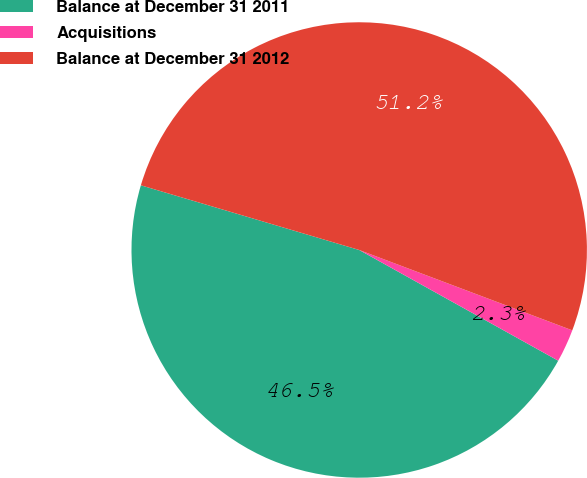<chart> <loc_0><loc_0><loc_500><loc_500><pie_chart><fcel>Balance at December 31 2011<fcel>Acquisitions<fcel>Balance at December 31 2012<nl><fcel>46.5%<fcel>2.34%<fcel>51.15%<nl></chart> 